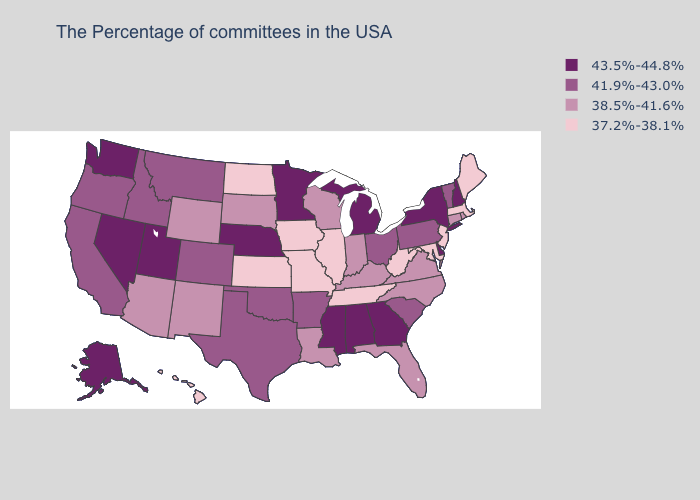Does Missouri have a lower value than North Dakota?
Quick response, please. No. What is the lowest value in states that border Massachusetts?
Concise answer only. 38.5%-41.6%. Does the first symbol in the legend represent the smallest category?
Write a very short answer. No. Does Colorado have the same value as California?
Give a very brief answer. Yes. What is the value of Florida?
Keep it brief. 38.5%-41.6%. What is the highest value in the MidWest ?
Concise answer only. 43.5%-44.8%. Name the states that have a value in the range 38.5%-41.6%?
Concise answer only. Rhode Island, Connecticut, Virginia, North Carolina, Florida, Kentucky, Indiana, Wisconsin, Louisiana, South Dakota, Wyoming, New Mexico, Arizona. Name the states that have a value in the range 43.5%-44.8%?
Be succinct. New Hampshire, New York, Delaware, Georgia, Michigan, Alabama, Mississippi, Minnesota, Nebraska, Utah, Nevada, Washington, Alaska. What is the lowest value in states that border Utah?
Be succinct. 38.5%-41.6%. Which states have the lowest value in the South?
Keep it brief. Maryland, West Virginia, Tennessee. Among the states that border Idaho , does Washington have the highest value?
Be succinct. Yes. What is the value of New York?
Keep it brief. 43.5%-44.8%. What is the value of Montana?
Answer briefly. 41.9%-43.0%. Which states hav the highest value in the South?
Write a very short answer. Delaware, Georgia, Alabama, Mississippi. What is the lowest value in the West?
Write a very short answer. 37.2%-38.1%. 